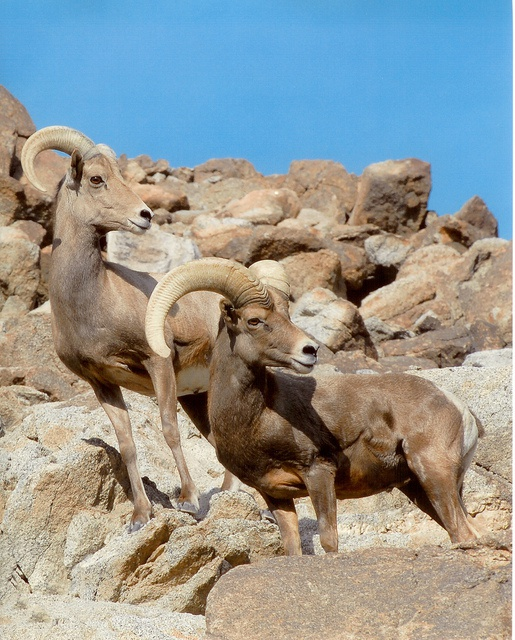Describe the objects in this image and their specific colors. I can see sheep in lightblue, gray, black, tan, and maroon tones and sheep in lightblue, gray, and tan tones in this image. 